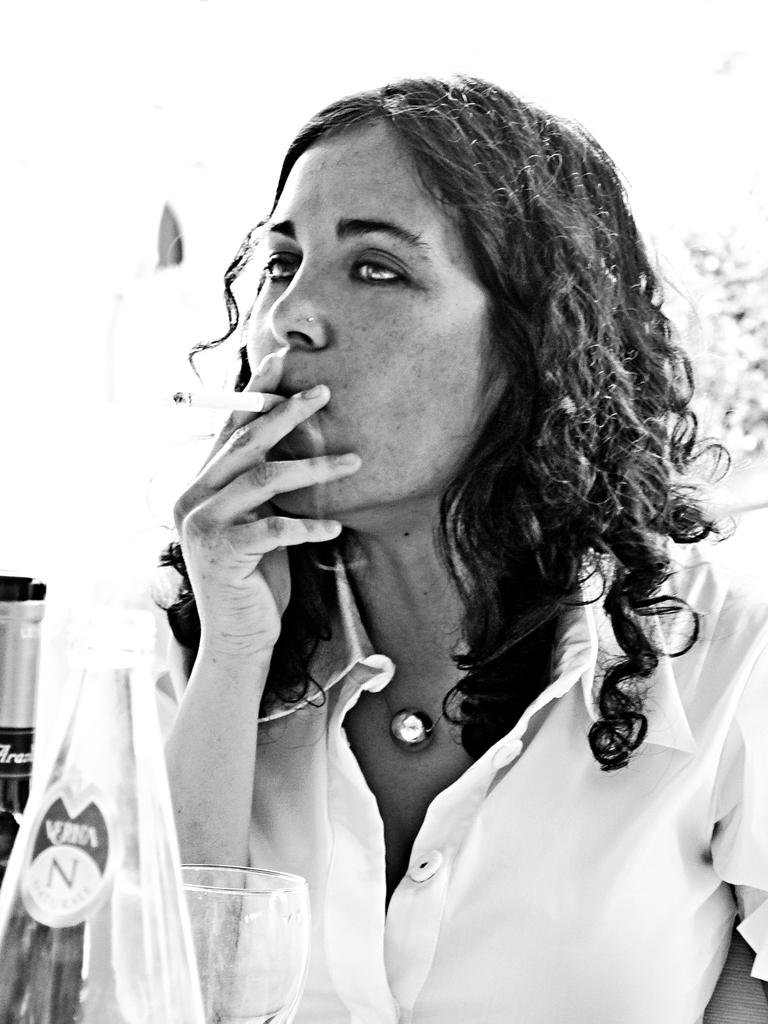Who is present in the image? There is a woman in the image. What is the woman wearing? The woman is wearing a white shirt. What is the woman doing in the image? The woman is smoking. What items are in front of the woman? There are wine bottles, a glass, and a water bottle in front of the woman. What can be seen in the background of the image? There is a wall visible in the background. Can you tell me how many times the woman touches the waste bin in the image? There is no waste bin present in the image, so it is not possible to determine how many times the woman touches it. 